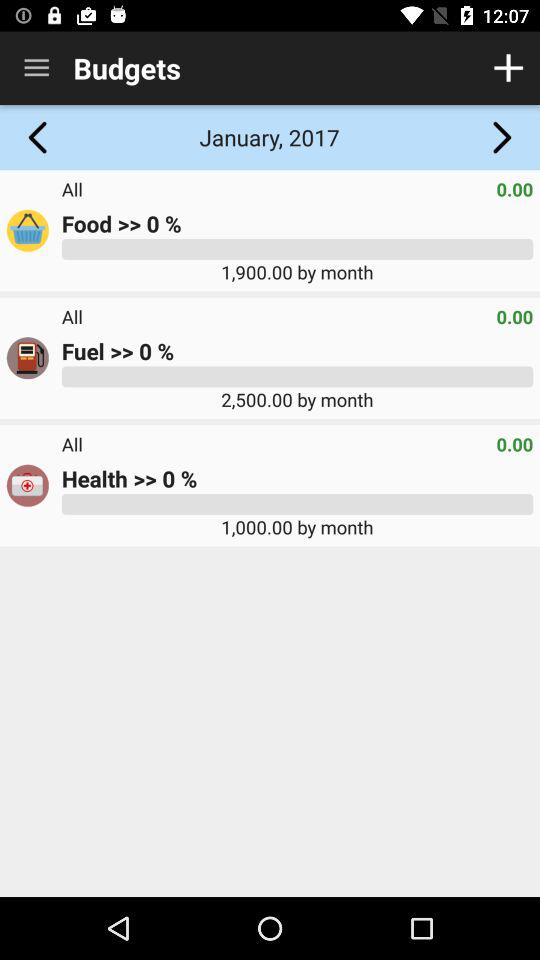Which item has a budget of 1,000? The item that has a budget of 1,000 is "Health". 